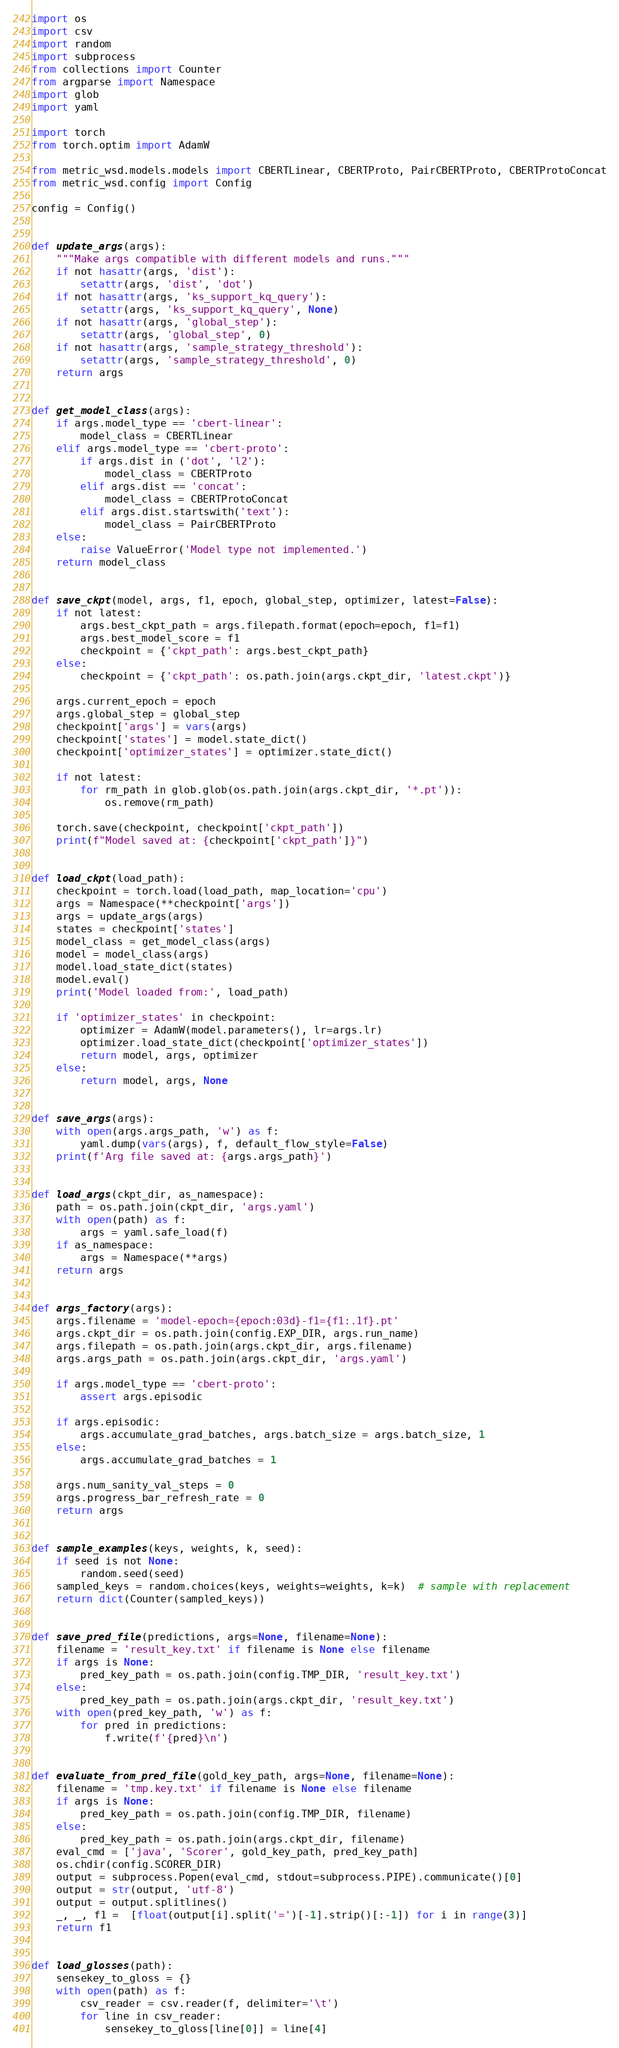Convert code to text. <code><loc_0><loc_0><loc_500><loc_500><_Python_>import os
import csv
import random
import subprocess
from collections import Counter
from argparse import Namespace
import glob
import yaml

import torch
from torch.optim import AdamW

from metric_wsd.models.models import CBERTLinear, CBERTProto, PairCBERTProto, CBERTProtoConcat
from metric_wsd.config import Config

config = Config()


def update_args(args):
    """Make args compatible with different models and runs."""
    if not hasattr(args, 'dist'):
        setattr(args, 'dist', 'dot')
    if not hasattr(args, 'ks_support_kq_query'):
        setattr(args, 'ks_support_kq_query', None)
    if not hasattr(args, 'global_step'):
        setattr(args, 'global_step', 0)
    if not hasattr(args, 'sample_strategy_threshold'):
        setattr(args, 'sample_strategy_threshold', 0)
    return args


def get_model_class(args):
    if args.model_type == 'cbert-linear':
        model_class = CBERTLinear
    elif args.model_type == 'cbert-proto':
        if args.dist in ('dot', 'l2'):
            model_class = CBERTProto
        elif args.dist == 'concat':
            model_class = CBERTProtoConcat
        elif args.dist.startswith('text'):
            model_class = PairCBERTProto
    else:
        raise ValueError('Model type not implemented.')
    return model_class


def save_ckpt(model, args, f1, epoch, global_step, optimizer, latest=False):
    if not latest:
        args.best_ckpt_path = args.filepath.format(epoch=epoch, f1=f1)
        args.best_model_score = f1
        checkpoint = {'ckpt_path': args.best_ckpt_path}
    else:
        checkpoint = {'ckpt_path': os.path.join(args.ckpt_dir, 'latest.ckpt')}

    args.current_epoch = epoch
    args.global_step = global_step
    checkpoint['args'] = vars(args)
    checkpoint['states'] = model.state_dict()
    checkpoint['optimizer_states'] = optimizer.state_dict()

    if not latest:
        for rm_path in glob.glob(os.path.join(args.ckpt_dir, '*.pt')):
            os.remove(rm_path)

    torch.save(checkpoint, checkpoint['ckpt_path'])
    print(f"Model saved at: {checkpoint['ckpt_path']}")


def load_ckpt(load_path):
    checkpoint = torch.load(load_path, map_location='cpu')
    args = Namespace(**checkpoint['args'])
    args = update_args(args)
    states = checkpoint['states']
    model_class = get_model_class(args)
    model = model_class(args)
    model.load_state_dict(states)
    model.eval()
    print('Model loaded from:', load_path)

    if 'optimizer_states' in checkpoint:
        optimizer = AdamW(model.parameters(), lr=args.lr)
        optimizer.load_state_dict(checkpoint['optimizer_states'])
        return model, args, optimizer
    else:
        return model, args, None


def save_args(args):
    with open(args.args_path, 'w') as f:
        yaml.dump(vars(args), f, default_flow_style=False)
    print(f'Arg file saved at: {args.args_path}')


def load_args(ckpt_dir, as_namespace):
    path = os.path.join(ckpt_dir, 'args.yaml')
    with open(path) as f:
        args = yaml.safe_load(f)
    if as_namespace:
        args = Namespace(**args)
    return args


def args_factory(args):
    args.filename = 'model-epoch={epoch:03d}-f1={f1:.1f}.pt'
    args.ckpt_dir = os.path.join(config.EXP_DIR, args.run_name)
    args.filepath = os.path.join(args.ckpt_dir, args.filename)
    args.args_path = os.path.join(args.ckpt_dir, 'args.yaml')

    if args.model_type == 'cbert-proto':
        assert args.episodic

    if args.episodic:
        args.accumulate_grad_batches, args.batch_size = args.batch_size, 1
    else:
        args.accumulate_grad_batches = 1
    
    args.num_sanity_val_steps = 0
    args.progress_bar_refresh_rate = 0
    return args


def sample_examples(keys, weights, k, seed):
    if seed is not None:
        random.seed(seed)
    sampled_keys = random.choices(keys, weights=weights, k=k)  # sample with replacement
    return dict(Counter(sampled_keys))


def save_pred_file(predictions, args=None, filename=None):
    filename = 'result_key.txt' if filename is None else filename
    if args is None:
        pred_key_path = os.path.join(config.TMP_DIR, 'result_key.txt')
    else:
        pred_key_path = os.path.join(args.ckpt_dir, 'result_key.txt')
    with open(pred_key_path, 'w') as f:
        for pred in predictions:
            f.write(f'{pred}\n')


def evaluate_from_pred_file(gold_key_path, args=None, filename=None):
    filename = 'tmp.key.txt' if filename is None else filename
    if args is None:
        pred_key_path = os.path.join(config.TMP_DIR, filename)
    else:
        pred_key_path = os.path.join(args.ckpt_dir, filename)
    eval_cmd = ['java', 'Scorer', gold_key_path, pred_key_path]
    os.chdir(config.SCORER_DIR)
    output = subprocess.Popen(eval_cmd, stdout=subprocess.PIPE).communicate()[0]
    output = str(output, 'utf-8')
    output = output.splitlines()
    _, _, f1 =  [float(output[i].split('=')[-1].strip()[:-1]) for i in range(3)]
    return f1


def load_glosses(path):
    sensekey_to_gloss = {}
    with open(path) as f:
        csv_reader = csv.reader(f, delimiter='\t')
        for line in csv_reader:
            sensekey_to_gloss[line[0]] = line[4]</code> 